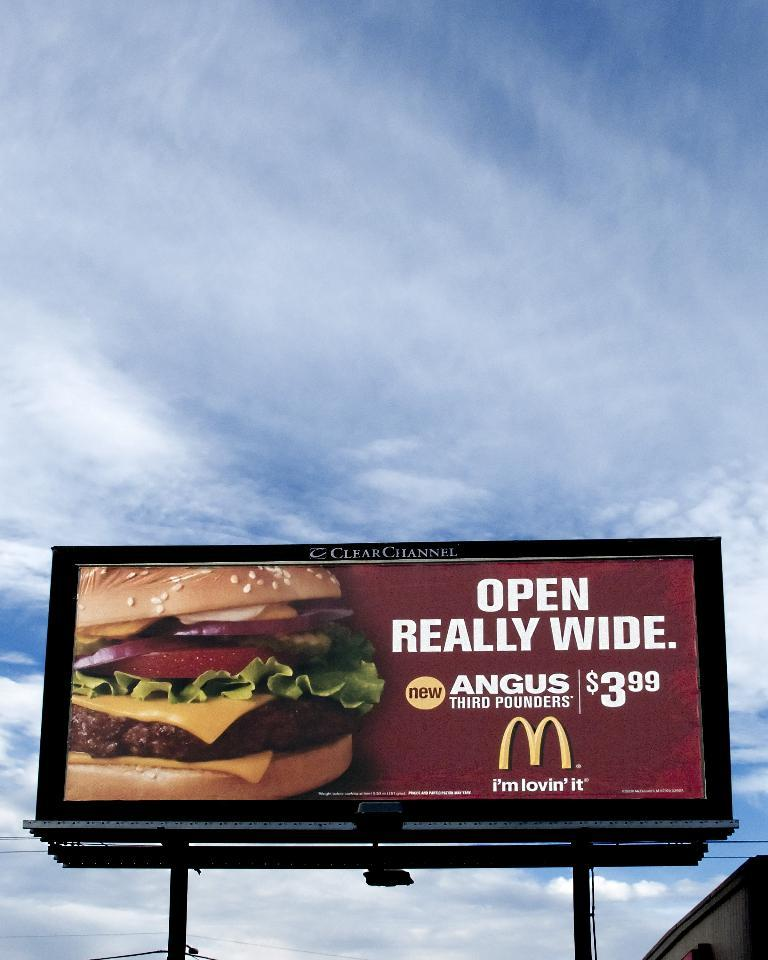<image>
Give a short and clear explanation of the subsequent image. A billboard with a Mcdonald's image of a burger on it. 